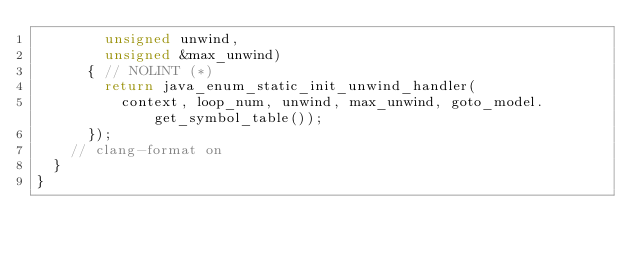<code> <loc_0><loc_0><loc_500><loc_500><_C++_>        unsigned unwind,
        unsigned &max_unwind)
      { // NOLINT (*)
        return java_enum_static_init_unwind_handler(
          context, loop_num, unwind, max_unwind, goto_model.get_symbol_table());
      });
    // clang-format on
  }
}
</code> 